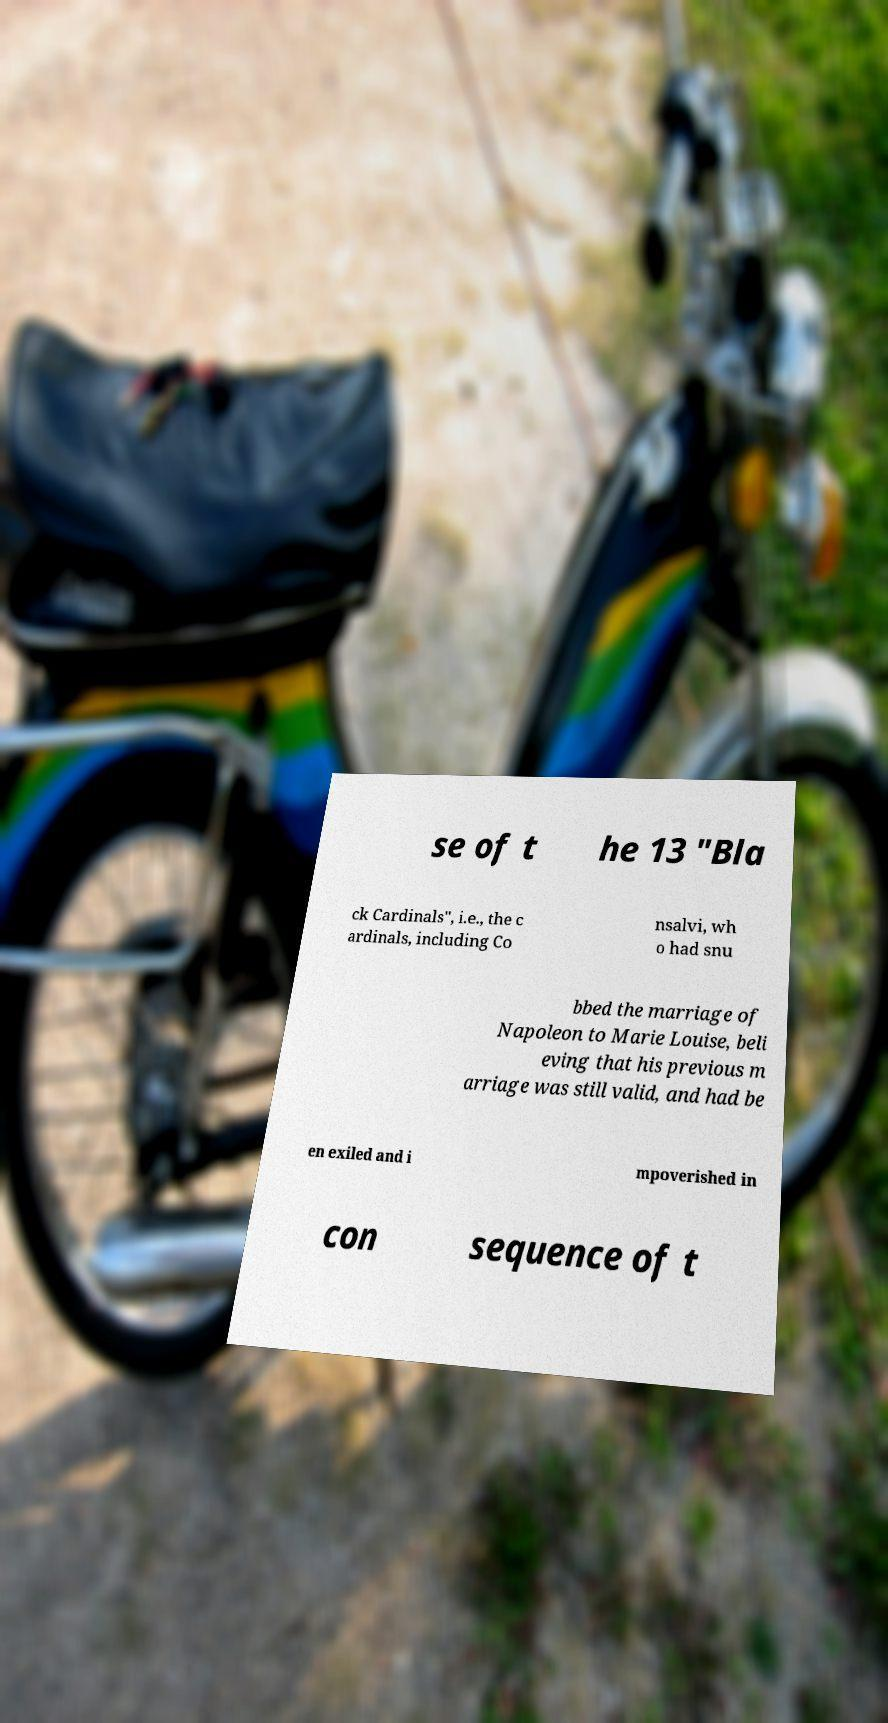Can you accurately transcribe the text from the provided image for me? se of t he 13 "Bla ck Cardinals", i.e., the c ardinals, including Co nsalvi, wh o had snu bbed the marriage of Napoleon to Marie Louise, beli eving that his previous m arriage was still valid, and had be en exiled and i mpoverished in con sequence of t 